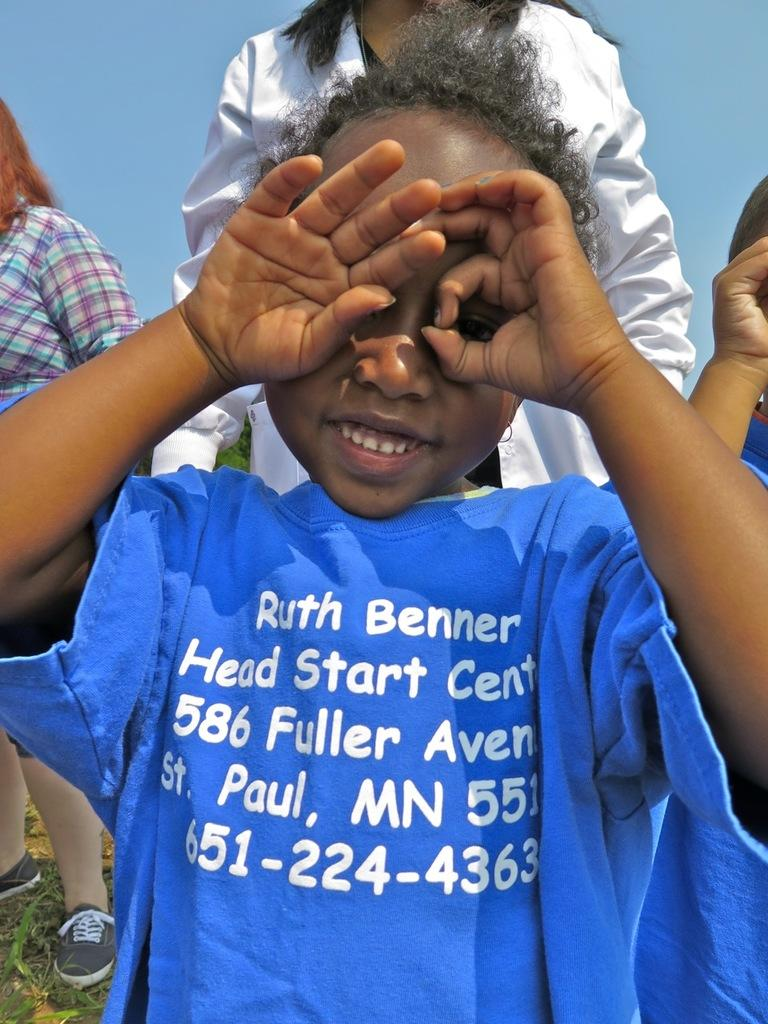What is the main subject of the image? The main subject of the image is a group of people. What colors are the dresses worn by the people in the image? The people are wearing blue, white, and purple dresses. Where are the people standing in the image? The people are standing on the ground. What color is the sky in the image? The sky is blue in the image. What type of scale can be seen in the image? There is no scale present in the image. Are the people in the image participating in a skate competition? There is no indication of a skate competition in the image; the people are simply standing on the ground. 